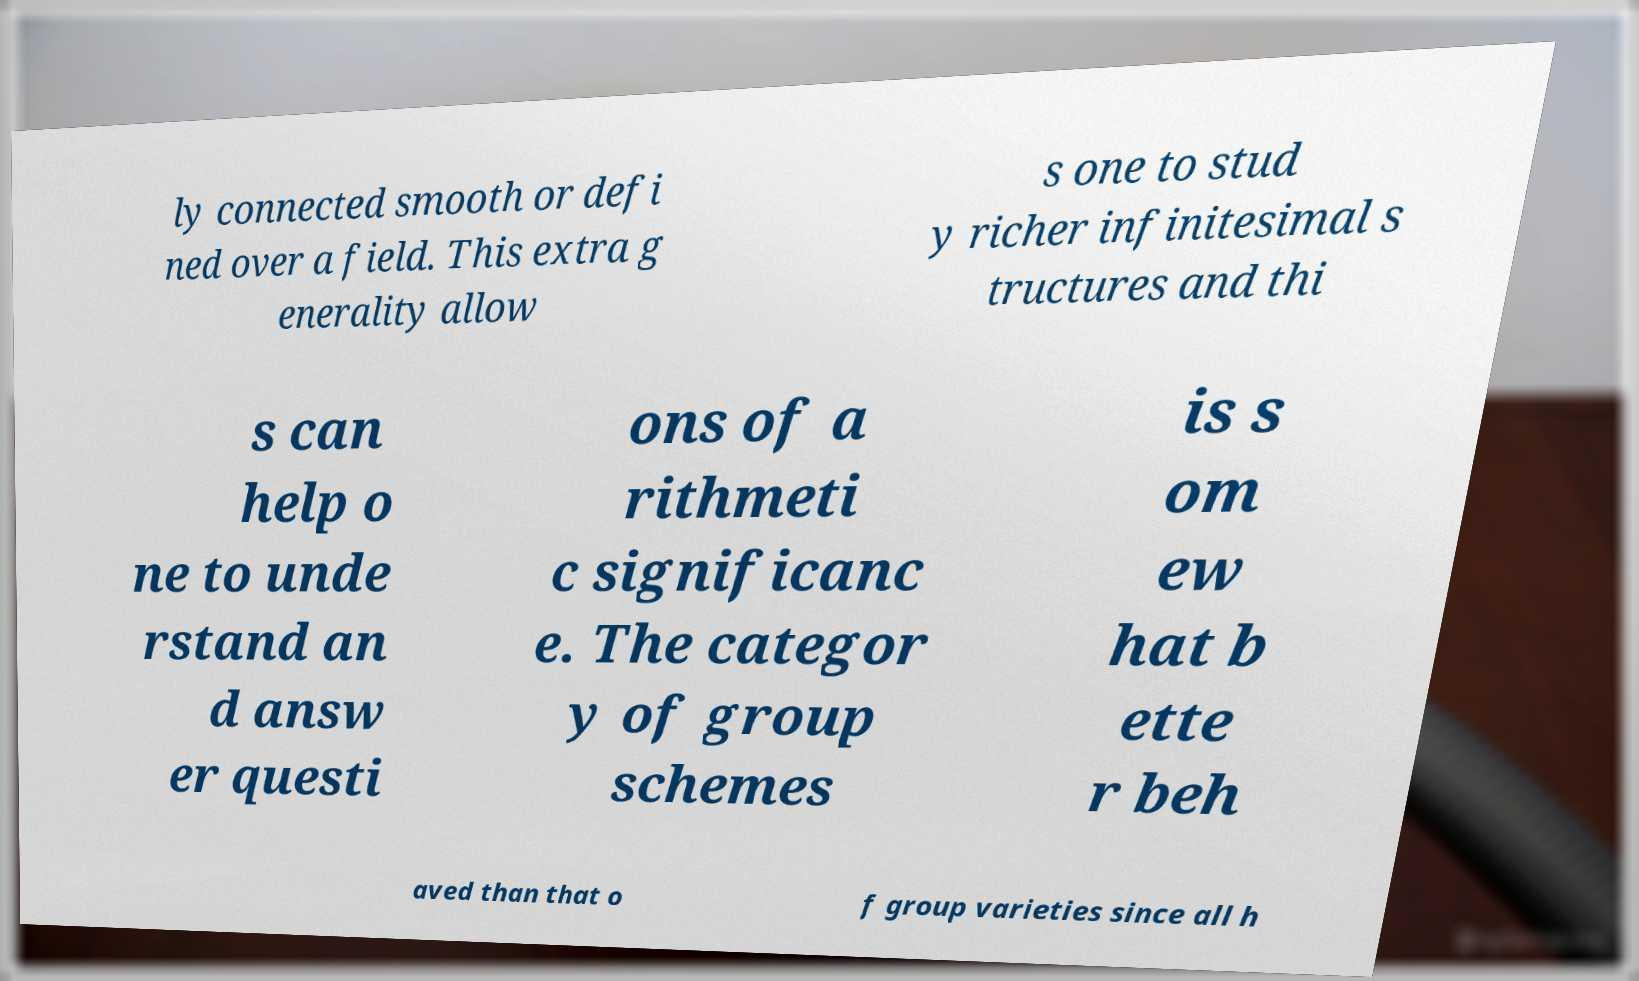Please read and relay the text visible in this image. What does it say? ly connected smooth or defi ned over a field. This extra g enerality allow s one to stud y richer infinitesimal s tructures and thi s can help o ne to unde rstand an d answ er questi ons of a rithmeti c significanc e. The categor y of group schemes is s om ew hat b ette r beh aved than that o f group varieties since all h 